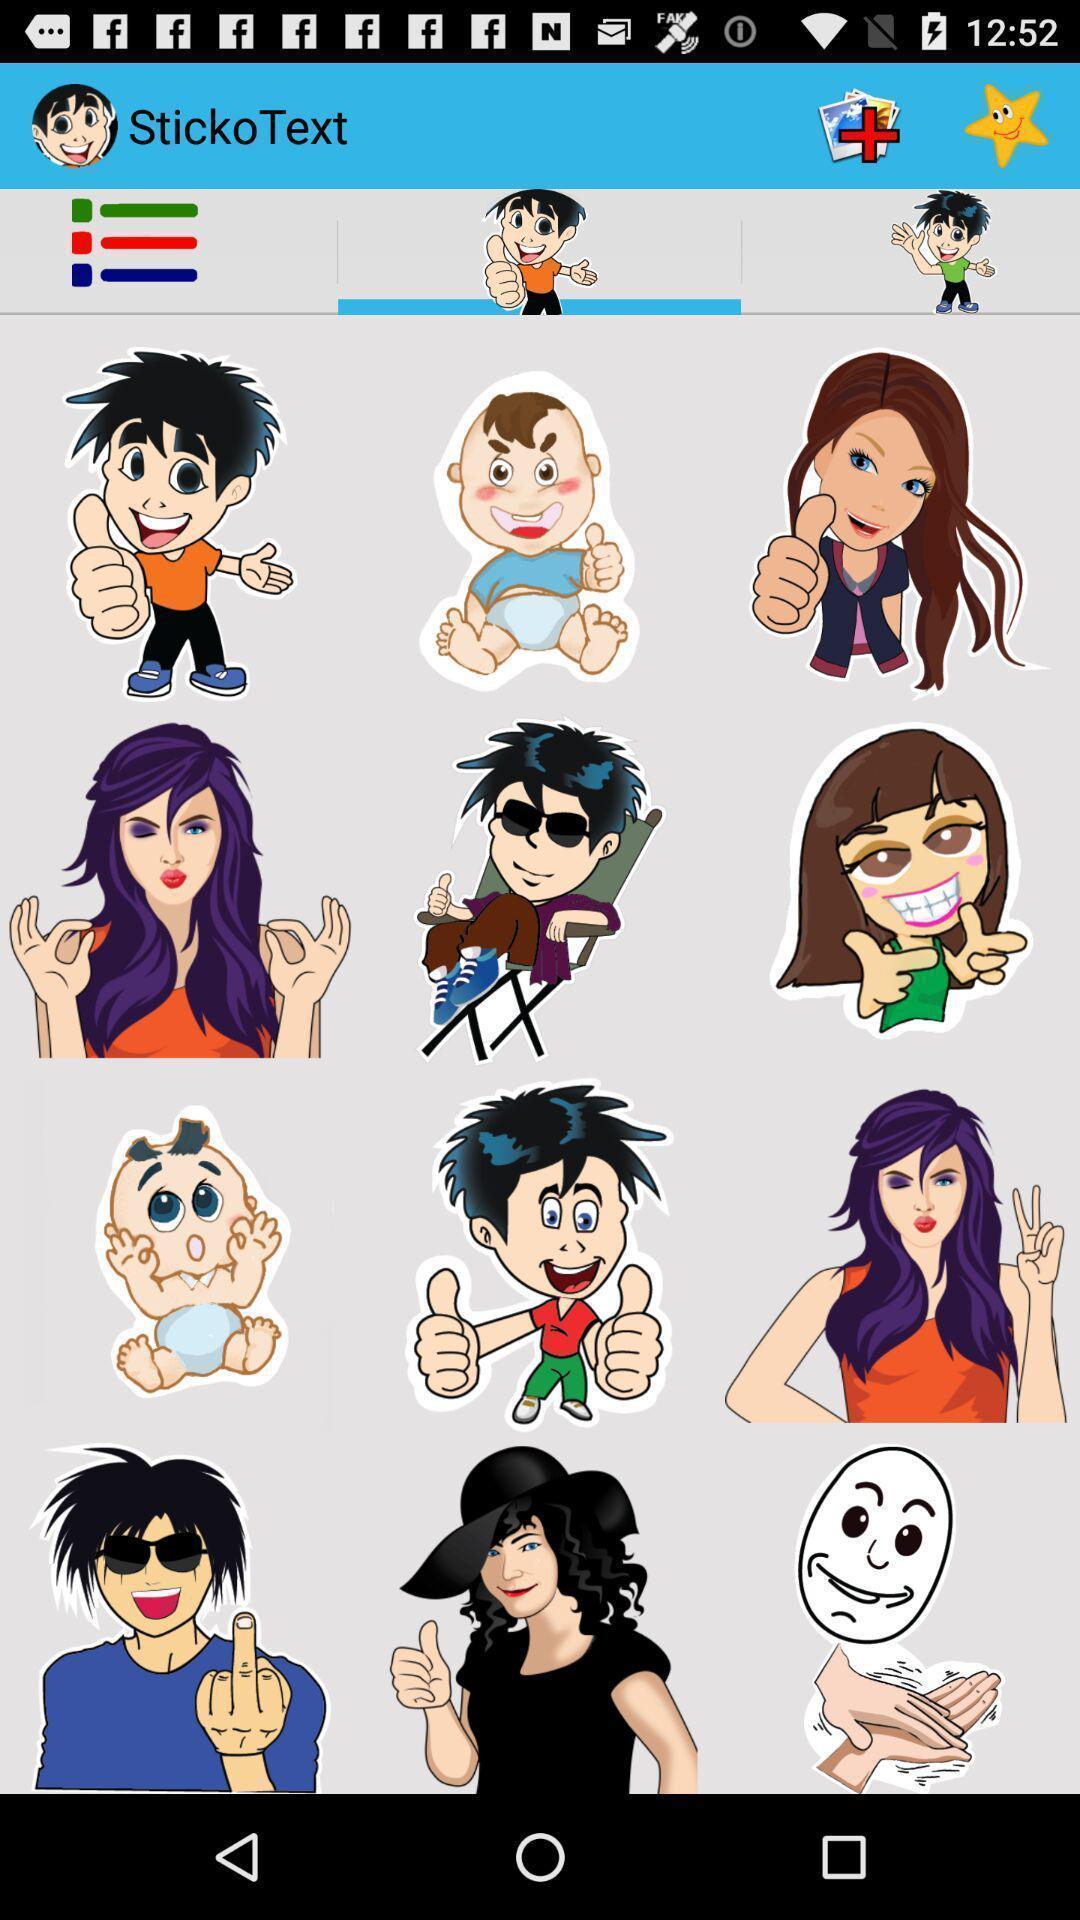Give me a summary of this screen capture. Page shows number of images in the photo app. 